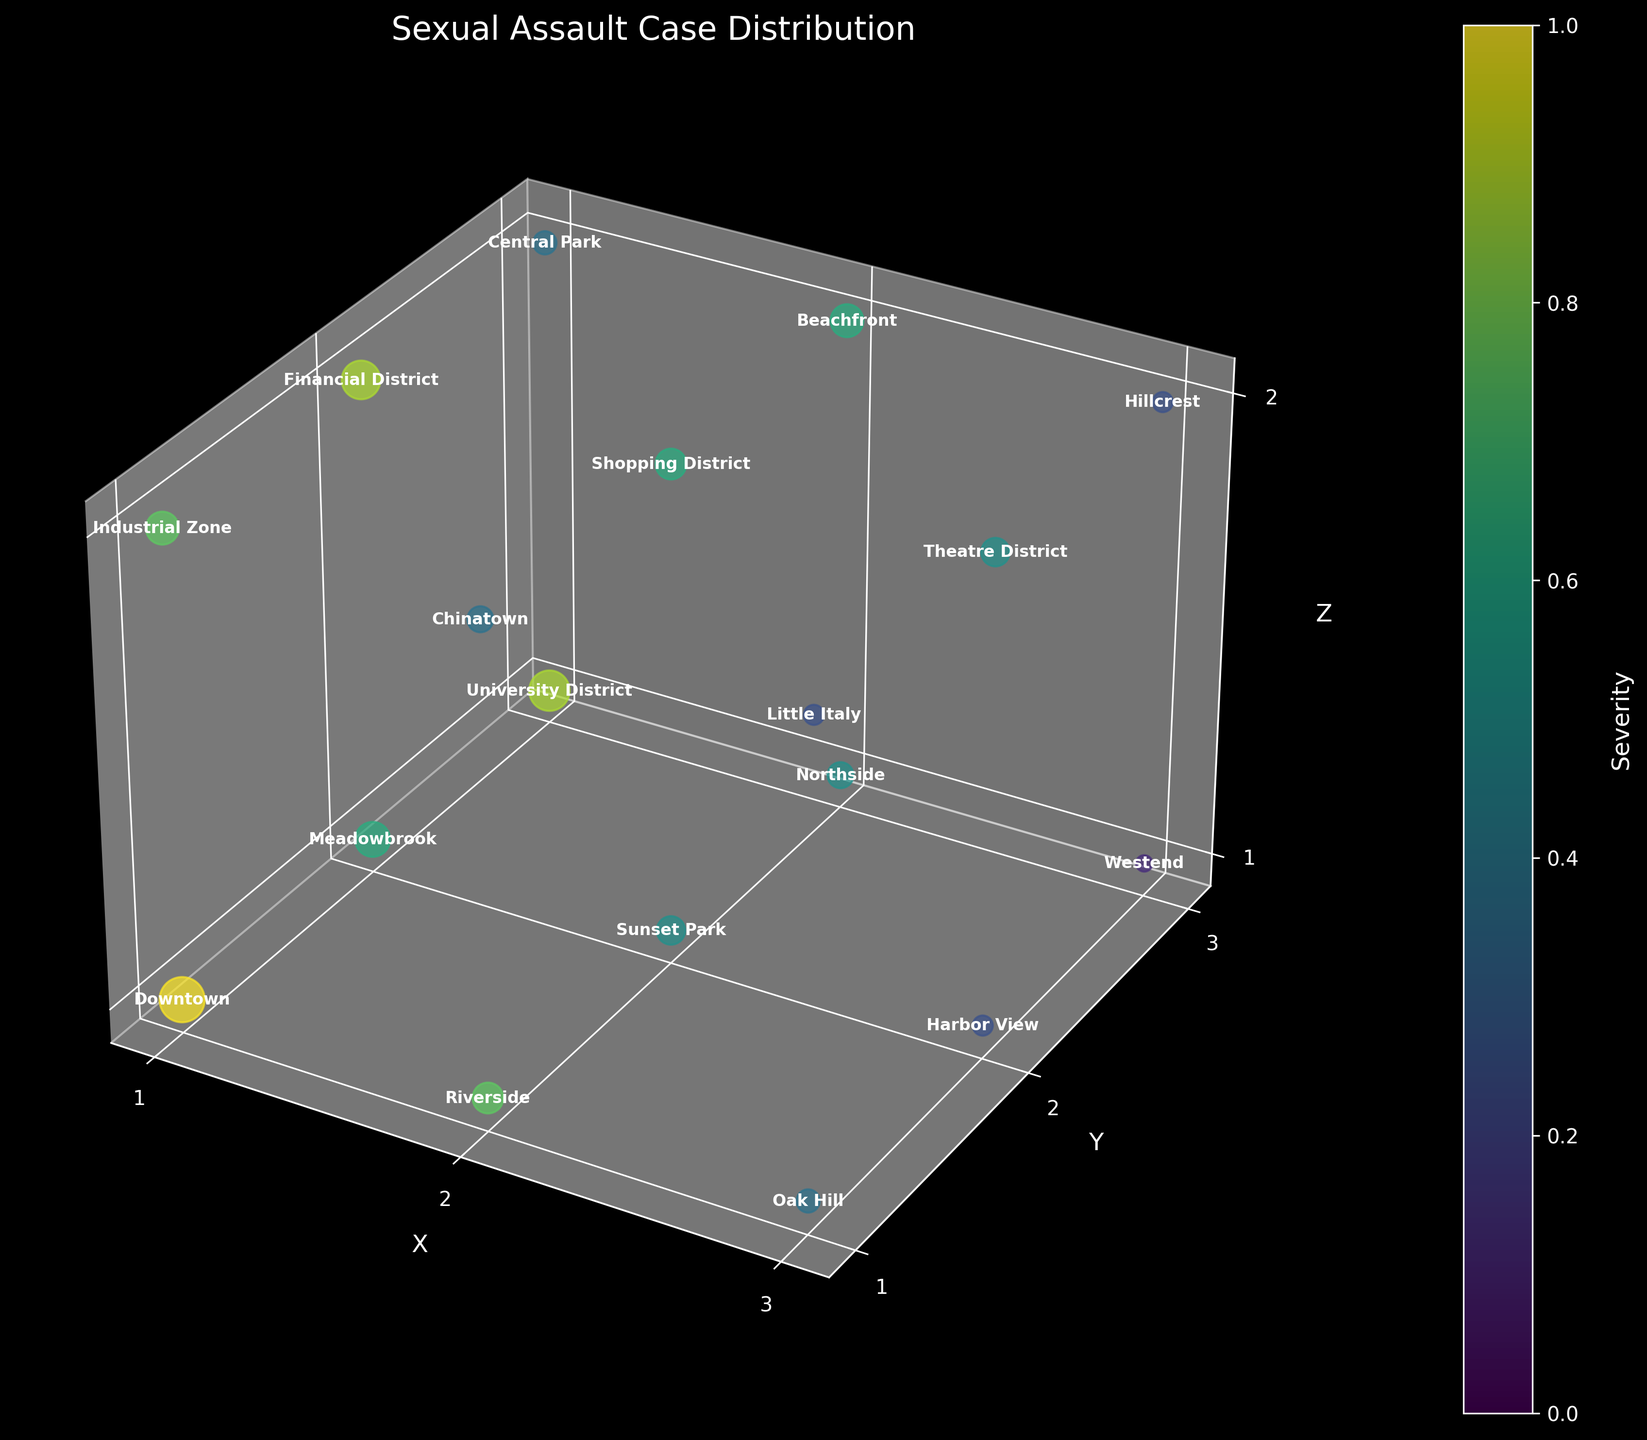What's the title of the figure? The title of a figure usually gives a broad overview of what the data represents. In the 3D voxel figure, the title "Sexual Assault Case Distribution" suggests that the plot shows how the frequency and severity of sexual assault cases are distributed across various locations.
Answer: Sexual Assault Case Distribution How many neighborhoods are represented in the figure? To find the number of neighborhoods, count the number of unique data points in the figure. Each data point has a neighborhood label attached to it.
Answer: 18 Which neighborhood has the highest frequency of sexual assault cases? Identify the voxel with the largest size (since size represents frequency). By examining the figure, it is clear that "Downtown" has the largest voxel, indicating the highest frequency.
Answer: Downtown Which neighborhood has the highest severity of sexual assault cases? Look for the voxel with the most intense color in the color gradient representing severity. The figure shows that "Downtown" and "University District" both have high severity levels, but "Downtown" is slightly higher.
Answer: Downtown In which plane (e.g., Z=1) are most cases concentrated? To determine this, count the number of data points or voxels at each Z plane. The Z=1 plane visually has the most voxels representing various neighborhoods.
Answer: Z=1 What's the average severity of sexual assault cases in the Downtown and Financial District combined? First, find the severity values for Downtown (8) and Financial District (7). Next, calculate the average: (8 + 7) / 2 = 7.5.
Answer: 7.5 What's the difference in frequency between Downtown and Westend? Determine the frequency values for Downtown (15) and Westend (2). Then, calculate the difference: 15 - 2 = 13.
Answer: 13 Which area has a higher severity: Riverside or Beachfront? Compare the severity values of Riverside (6) and Beachfront (5). Riverside has a higher severity.
Answer: Riverside How does the severity of cases in Oak Hill compare to those in Northside? Check the severity values: Oak Hill (3) and Northside (4). Northside has a higher severity.
Answer: Northside Which neighborhoods are in the Z=2 plane? Identify and list the neighborhoods aligned with Z=2 by their positioning in the figure. The neighborhoods in the Z=2 plane are "Industrial Zone," "Chinatown," "Little Italy," "Financial District," "Shopping District," "Theatre District," "Central Park," "Beachfront," and "Hillcrest."
Answer: Industrial Zone, Chinatown, Little Italy, Financial District, Shopping District, Theatre District, Central Park, Beachfront, Hillcrest 